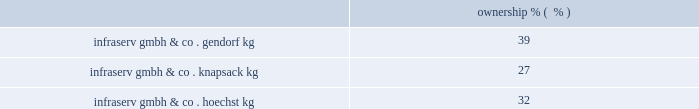Korea engineering plastics co. , ltd .
Founded in 1987 , kepco is the leading producer of pom in south korea .
Kepco is a venture between celanese's ticona business ( 50% ( 50 % ) ) , mitsubishi gas chemical company , inc .
( 40% ( 40 % ) ) and mitsubishi corporation ( 10% ( 10 % ) ) .
Kepco has polyacetal production facilities in ulsan , south korea , compounding facilities for pbt and nylon in pyongtaek , south korea , and participates with polyplastics and mitsubishi gas chemical company , inc .
In a world-scale pom facility in nantong , china .
Polyplastics co. , ltd .
Polyplastics is a leading supplier of engineered plastics in the asia-pacific region and is a venture between daicel chemical industries ltd. , japan ( 55% ( 55 % ) ) , and celanese's ticona business ( 45% ( 45 % ) ) .
Established in 1964 , polyplastics is a producer and marketer of pom and lcp in the asia-pacific region , with principal production facilities located in japan , taiwan , malaysia and china .
Fortron industries llc .
Fortron is a leading global producer of polyphenylene sulfide ( 201cpps 201d ) , sold under the fortron ae brand , which is used in a wide variety of automotive and other applications , especially those requiring heat and/or chemical resistance .
Established in 1992 , fortron is a limited liability company whose members are ticona fortron inc .
( 50% ( 50 % ) ownership and a wholly-owned subsidiary of cna holdings , llc ) and kureha corporation ( 50% ( 50 % ) ownership and a wholly-owned subsidiary of kureha chemical industry co. , ltd .
Of japan ) .
Fortron's facility is located in wilmington , north carolina .
This venture combines the sales , marketing , distribution , compounding and manufacturing expertise of celanese with the pps polymer technology expertise of kureha .
China acetate strategic ventures .
We hold an approximate 30% ( 30 % ) ownership interest in three separate acetate production ventures in china .
These include the nantong cellulose fibers co .
Ltd. , kunming cellulose fibers co .
Ltd .
And zhuhai cellulose fibers co .
Ltd .
The china national tobacco corporation , the chinese state-owned tobacco entity , controls the remaining ownership interest in each of these ventures .
With an estimated 30% ( 30 % ) share of the world's cigarette production and consumption , china is the world's largest and fastest growing area for acetate tow products according to the 2009 stanford research institute international chemical economics handbook .
Combined , these ventures are a leader in chinese domestic acetate production and are well positioned to supply chinese cigarette producers .
In december 2009 , we announced plans with china national tobacco to expand our acetate flake and tow capacity at our venture's nantong facility and we received formal approval for the expansions , each by 30000 tons , during 2010 .
Since their inception in 1986 , the china acetate ventures have completed 12 expansions , leading to earnings growth and increased dividends .
Our chinese acetate ventures fund their operations using operating cash flow .
During 2011 , we made contributions of $ 8 million related to the capacity expansions in nantong and have committed contributions of $ 9 million in 2012 .
In 2010 , we made contributions of $ 12 million .
Our chinese acetate ventures pay a dividend in the second quarter of each fiscal year , based on the ventures' performance for the preceding year .
In 2011 , 2010 and 2009 , we received cash dividends of $ 78 million , $ 71 million and $ 56 million , respectively .
Although our ownership interest in each of our china acetate ventures exceeds 20% ( 20 % ) , we account for these investments using the cost method of accounting because we determined that we cannot exercise significant influence over these entities due to local government investment in and influence over these entities , limitations on our involvement in the day-to-day operations and the present inability of the entities to provide timely financial information prepared in accordance with generally accepted accounting principles in the united states ( 201cus gaap 201d ) .
2022 other equity method investments infraservs .
We hold indirect ownership interests in several infraserv groups in germany that own and develop industrial parks and provide on-site general and administrative support to tenants .
The table below represents our equity investments in infraserv ventures as of december 31 , 2011: .

What is the growth rate in cash dividends received in 2010 compare to 2009? 
Computations: ((71 - 56) / 56)
Answer: 0.26786. Korea engineering plastics co. , ltd .
Founded in 1987 , kepco is the leading producer of pom in south korea .
Kepco is a venture between celanese's ticona business ( 50% ( 50 % ) ) , mitsubishi gas chemical company , inc .
( 40% ( 40 % ) ) and mitsubishi corporation ( 10% ( 10 % ) ) .
Kepco has polyacetal production facilities in ulsan , south korea , compounding facilities for pbt and nylon in pyongtaek , south korea , and participates with polyplastics and mitsubishi gas chemical company , inc .
In a world-scale pom facility in nantong , china .
Polyplastics co. , ltd .
Polyplastics is a leading supplier of engineered plastics in the asia-pacific region and is a venture between daicel chemical industries ltd. , japan ( 55% ( 55 % ) ) , and celanese's ticona business ( 45% ( 45 % ) ) .
Established in 1964 , polyplastics is a producer and marketer of pom and lcp in the asia-pacific region , with principal production facilities located in japan , taiwan , malaysia and china .
Fortron industries llc .
Fortron is a leading global producer of polyphenylene sulfide ( 201cpps 201d ) , sold under the fortron ae brand , which is used in a wide variety of automotive and other applications , especially those requiring heat and/or chemical resistance .
Established in 1992 , fortron is a limited liability company whose members are ticona fortron inc .
( 50% ( 50 % ) ownership and a wholly-owned subsidiary of cna holdings , llc ) and kureha corporation ( 50% ( 50 % ) ownership and a wholly-owned subsidiary of kureha chemical industry co. , ltd .
Of japan ) .
Fortron's facility is located in wilmington , north carolina .
This venture combines the sales , marketing , distribution , compounding and manufacturing expertise of celanese with the pps polymer technology expertise of kureha .
China acetate strategic ventures .
We hold an approximate 30% ( 30 % ) ownership interest in three separate acetate production ventures in china .
These include the nantong cellulose fibers co .
Ltd. , kunming cellulose fibers co .
Ltd .
And zhuhai cellulose fibers co .
Ltd .
The china national tobacco corporation , the chinese state-owned tobacco entity , controls the remaining ownership interest in each of these ventures .
With an estimated 30% ( 30 % ) share of the world's cigarette production and consumption , china is the world's largest and fastest growing area for acetate tow products according to the 2009 stanford research institute international chemical economics handbook .
Combined , these ventures are a leader in chinese domestic acetate production and are well positioned to supply chinese cigarette producers .
In december 2009 , we announced plans with china national tobacco to expand our acetate flake and tow capacity at our venture's nantong facility and we received formal approval for the expansions , each by 30000 tons , during 2010 .
Since their inception in 1986 , the china acetate ventures have completed 12 expansions , leading to earnings growth and increased dividends .
Our chinese acetate ventures fund their operations using operating cash flow .
During 2011 , we made contributions of $ 8 million related to the capacity expansions in nantong and have committed contributions of $ 9 million in 2012 .
In 2010 , we made contributions of $ 12 million .
Our chinese acetate ventures pay a dividend in the second quarter of each fiscal year , based on the ventures' performance for the preceding year .
In 2011 , 2010 and 2009 , we received cash dividends of $ 78 million , $ 71 million and $ 56 million , respectively .
Although our ownership interest in each of our china acetate ventures exceeds 20% ( 20 % ) , we account for these investments using the cost method of accounting because we determined that we cannot exercise significant influence over these entities due to local government investment in and influence over these entities , limitations on our involvement in the day-to-day operations and the present inability of the entities to provide timely financial information prepared in accordance with generally accepted accounting principles in the united states ( 201cus gaap 201d ) .
2022 other equity method investments infraservs .
We hold indirect ownership interests in several infraserv groups in germany that own and develop industrial parks and provide on-site general and administrative support to tenants .
The table below represents our equity investments in infraserv ventures as of december 31 , 2011: .

What was the percentage growth in the cash dividends from 2009 to 2010? 
Rationale: the percentage change is the difference from year to year divide by the earlier year balance
Computations: ((71 - 56) / 56)
Answer: 0.26786. 